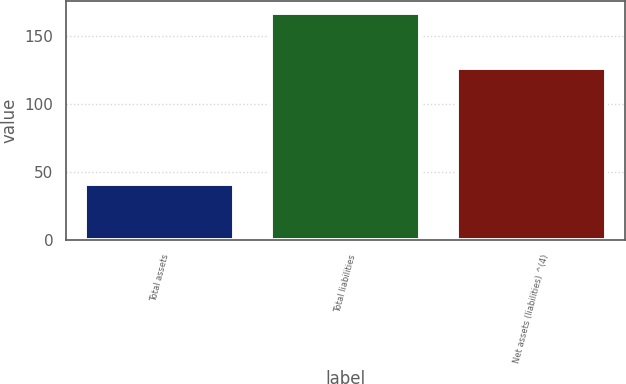Convert chart to OTSL. <chart><loc_0><loc_0><loc_500><loc_500><bar_chart><fcel>Total assets<fcel>Total liabilities<fcel>Net assets (liabilities) ^(4)<nl><fcel>41<fcel>167<fcel>126<nl></chart> 